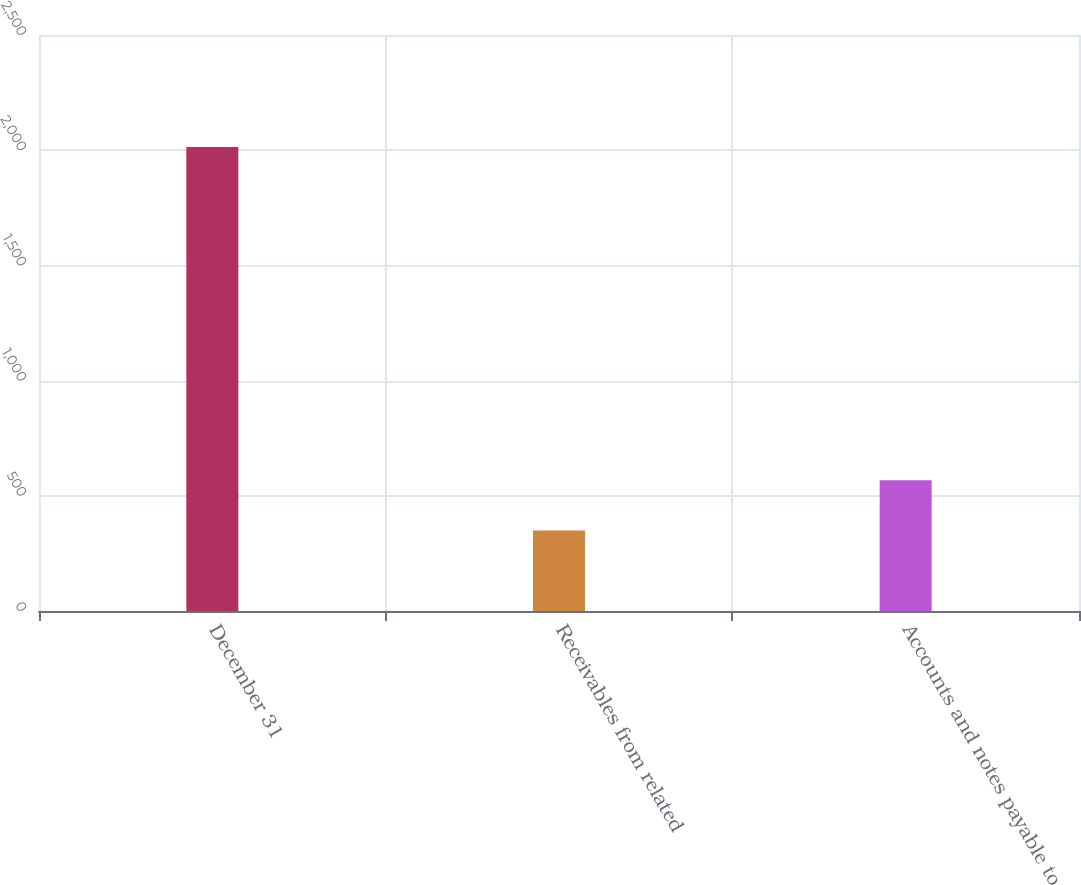Convert chart to OTSL. <chart><loc_0><loc_0><loc_500><loc_500><bar_chart><fcel>December 31<fcel>Receivables from related<fcel>Accounts and notes payable to<nl><fcel>2014<fcel>349<fcel>567<nl></chart> 